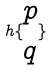Convert formula to latex. <formula><loc_0><loc_0><loc_500><loc_500>h \{ \begin{matrix} p \\ q \end{matrix} \}</formula> 